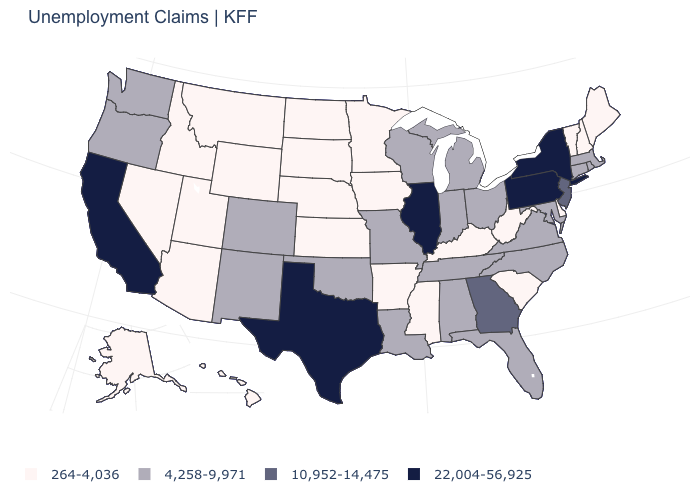Which states have the highest value in the USA?
Be succinct. California, Illinois, New York, Pennsylvania, Texas. What is the value of Massachusetts?
Give a very brief answer. 4,258-9,971. What is the value of Rhode Island?
Give a very brief answer. 4,258-9,971. What is the value of Arkansas?
Be succinct. 264-4,036. What is the value of Iowa?
Short answer required. 264-4,036. Name the states that have a value in the range 4,258-9,971?
Keep it brief. Alabama, Colorado, Connecticut, Florida, Indiana, Louisiana, Maryland, Massachusetts, Michigan, Missouri, New Mexico, North Carolina, Ohio, Oklahoma, Oregon, Rhode Island, Tennessee, Virginia, Washington, Wisconsin. Does Illinois have the highest value in the MidWest?
Concise answer only. Yes. Does the first symbol in the legend represent the smallest category?
Write a very short answer. Yes. What is the highest value in the South ?
Give a very brief answer. 22,004-56,925. What is the highest value in the Northeast ?
Keep it brief. 22,004-56,925. Does Wyoming have the highest value in the USA?
Be succinct. No. Among the states that border New Hampshire , which have the highest value?
Give a very brief answer. Massachusetts. Which states have the highest value in the USA?
Keep it brief. California, Illinois, New York, Pennsylvania, Texas. Does Vermont have the same value as Mississippi?
Give a very brief answer. Yes. 